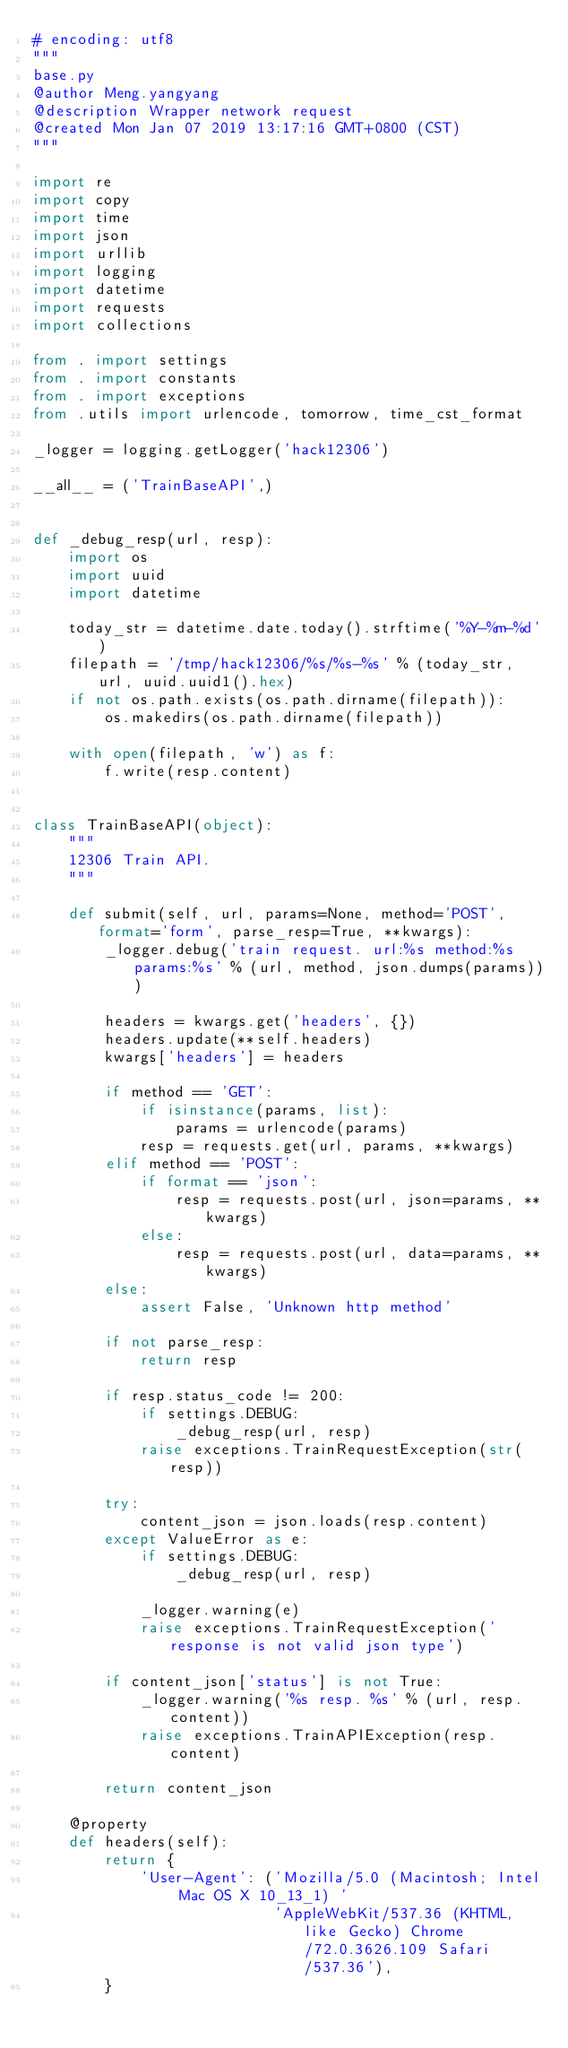Convert code to text. <code><loc_0><loc_0><loc_500><loc_500><_Python_># encoding: utf8
"""
base.py
@author Meng.yangyang
@description Wrapper network request
@created Mon Jan 07 2019 13:17:16 GMT+0800 (CST)
"""

import re
import copy
import time
import json
import urllib
import logging
import datetime
import requests
import collections

from . import settings
from . import constants
from . import exceptions
from .utils import urlencode, tomorrow, time_cst_format

_logger = logging.getLogger('hack12306')

__all__ = ('TrainBaseAPI',)


def _debug_resp(url, resp):
    import os
    import uuid
    import datetime

    today_str = datetime.date.today().strftime('%Y-%m-%d')
    filepath = '/tmp/hack12306/%s/%s-%s' % (today_str, url, uuid.uuid1().hex)
    if not os.path.exists(os.path.dirname(filepath)):
        os.makedirs(os.path.dirname(filepath))

    with open(filepath, 'w') as f:
        f.write(resp.content)


class TrainBaseAPI(object):
    """
    12306 Train API.
    """

    def submit(self, url, params=None, method='POST', format='form', parse_resp=True, **kwargs):
        _logger.debug('train request. url:%s method:%s params:%s' % (url, method, json.dumps(params)))

        headers = kwargs.get('headers', {})
        headers.update(**self.headers)
        kwargs['headers'] = headers

        if method == 'GET':
            if isinstance(params, list):
                params = urlencode(params)
            resp = requests.get(url, params, **kwargs)
        elif method == 'POST':
            if format == 'json':
                resp = requests.post(url, json=params, **kwargs)
            else:
                resp = requests.post(url, data=params, **kwargs)
        else:
            assert False, 'Unknown http method'

        if not parse_resp:
            return resp

        if resp.status_code != 200:
            if settings.DEBUG:
                _debug_resp(url, resp)
            raise exceptions.TrainRequestException(str(resp))

        try:
            content_json = json.loads(resp.content)
        except ValueError as e:
            if settings.DEBUG:
                _debug_resp(url, resp)

            _logger.warning(e)
            raise exceptions.TrainRequestException('response is not valid json type')

        if content_json['status'] is not True:
            _logger.warning('%s resp. %s' % (url, resp.content))
            raise exceptions.TrainAPIException(resp.content)

        return content_json

    @property
    def headers(self):
        return {
            'User-Agent': ('Mozilla/5.0 (Macintosh; Intel Mac OS X 10_13_1) '
                           'AppleWebKit/537.36 (KHTML, like Gecko) Chrome/72.0.3626.109 Safari/537.36'),
        }
</code> 